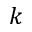<formula> <loc_0><loc_0><loc_500><loc_500>k</formula> 